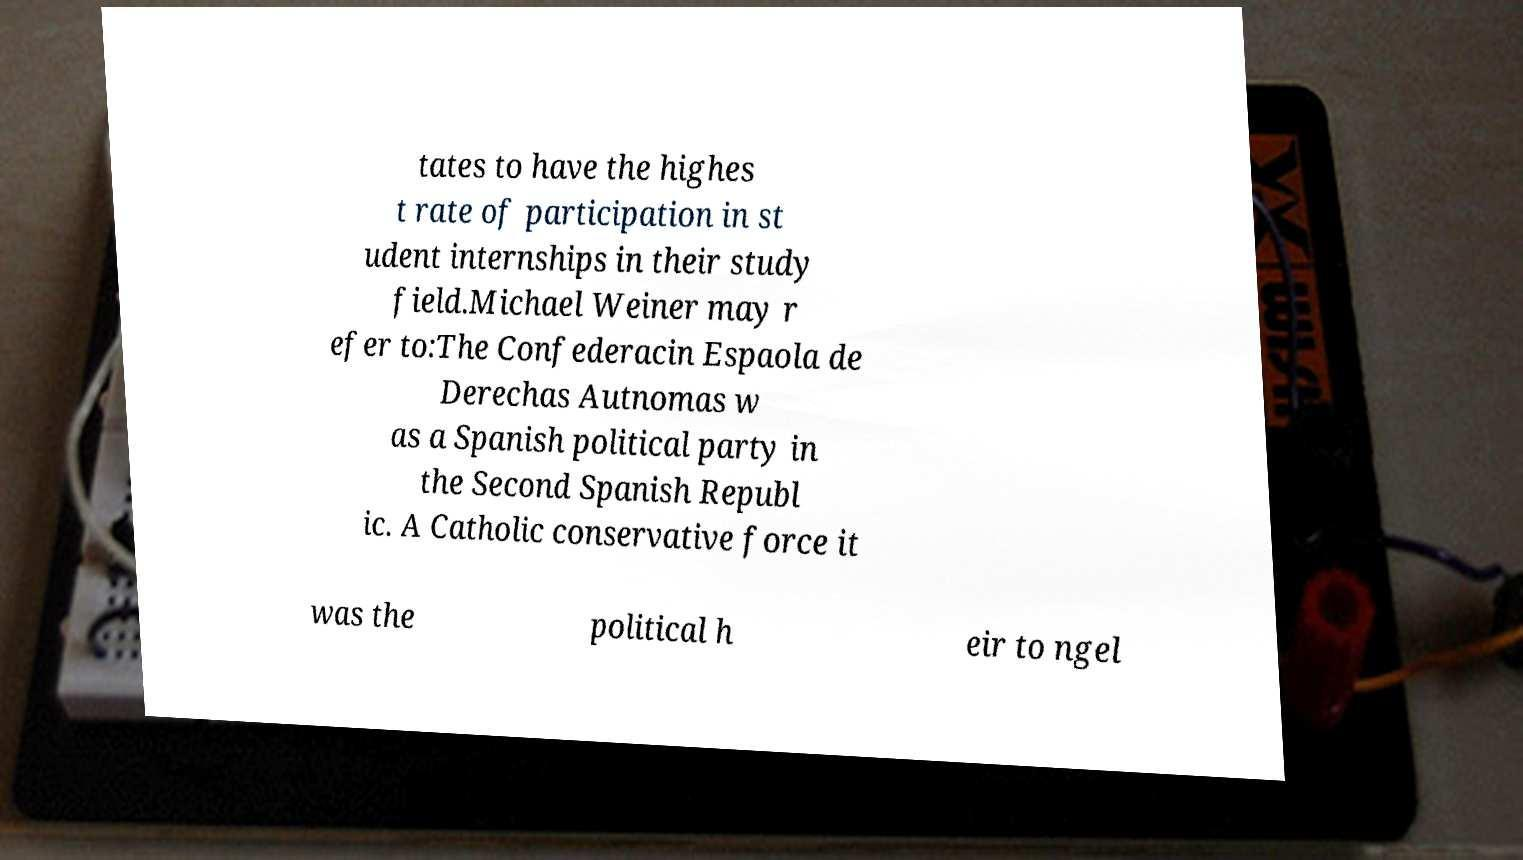Please read and relay the text visible in this image. What does it say? tates to have the highes t rate of participation in st udent internships in their study field.Michael Weiner may r efer to:The Confederacin Espaola de Derechas Autnomas w as a Spanish political party in the Second Spanish Republ ic. A Catholic conservative force it was the political h eir to ngel 